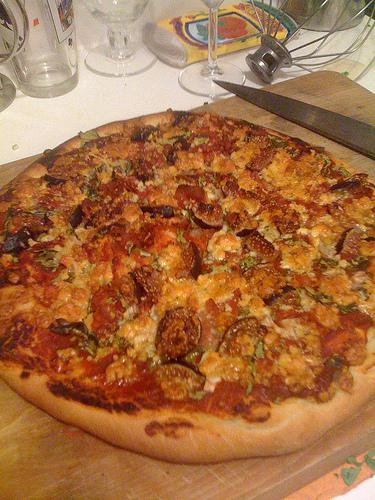Question: what is on the counter?
Choices:
A. Pizza.
B. Coffee.
C. A salad.
D. A steak.
Answer with the letter. Answer: A Question: where is the pizza?
Choices:
A. A table.
B. The floor.
C. Counter.
D. In the oven.
Answer with the letter. Answer: C Question: how many glasses are on the counter?
Choices:
A. Four.
B. Five.
C. Six.
D. Seven.
Answer with the letter. Answer: A 